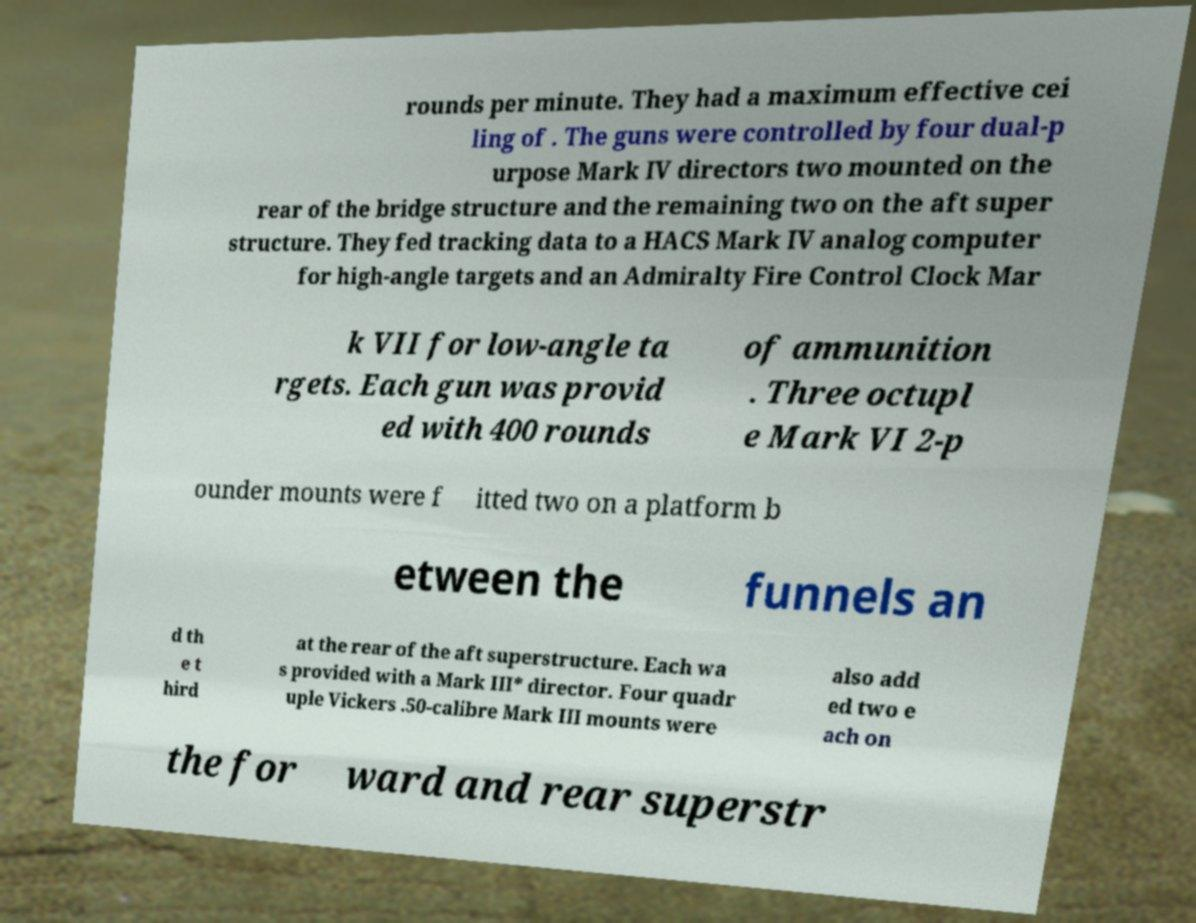For documentation purposes, I need the text within this image transcribed. Could you provide that? rounds per minute. They had a maximum effective cei ling of . The guns were controlled by four dual-p urpose Mark IV directors two mounted on the rear of the bridge structure and the remaining two on the aft super structure. They fed tracking data to a HACS Mark IV analog computer for high-angle targets and an Admiralty Fire Control Clock Mar k VII for low-angle ta rgets. Each gun was provid ed with 400 rounds of ammunition . Three octupl e Mark VI 2-p ounder mounts were f itted two on a platform b etween the funnels an d th e t hird at the rear of the aft superstructure. Each wa s provided with a Mark III* director. Four quadr uple Vickers .50-calibre Mark III mounts were also add ed two e ach on the for ward and rear superstr 